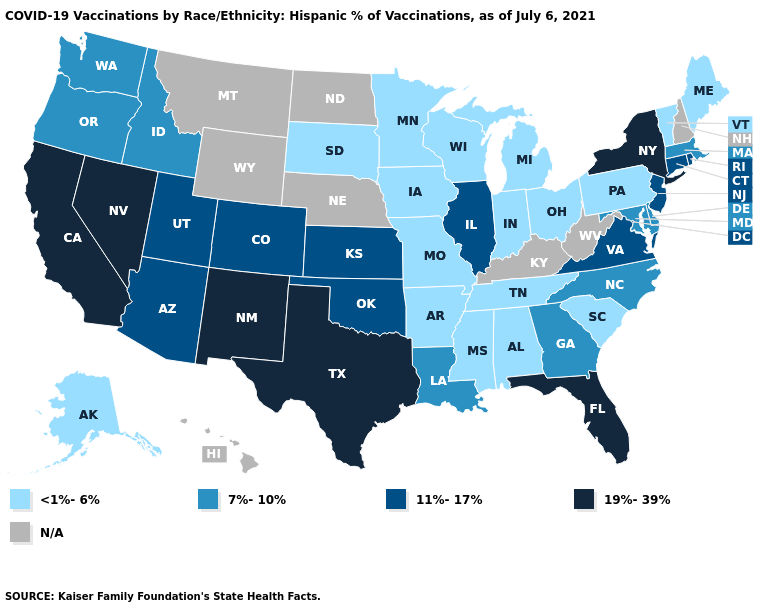Does Illinois have the highest value in the MidWest?
Short answer required. Yes. Does Pennsylvania have the lowest value in the USA?
Keep it brief. Yes. Name the states that have a value in the range N/A?
Be succinct. Hawaii, Kentucky, Montana, Nebraska, New Hampshire, North Dakota, West Virginia, Wyoming. Among the states that border New Mexico , does Texas have the highest value?
Keep it brief. Yes. What is the value of Iowa?
Concise answer only. <1%-6%. Name the states that have a value in the range 11%-17%?
Be succinct. Arizona, Colorado, Connecticut, Illinois, Kansas, New Jersey, Oklahoma, Rhode Island, Utah, Virginia. What is the highest value in the USA?
Keep it brief. 19%-39%. Does Louisiana have the lowest value in the USA?
Give a very brief answer. No. What is the value of Ohio?
Write a very short answer. <1%-6%. Name the states that have a value in the range <1%-6%?
Answer briefly. Alabama, Alaska, Arkansas, Indiana, Iowa, Maine, Michigan, Minnesota, Mississippi, Missouri, Ohio, Pennsylvania, South Carolina, South Dakota, Tennessee, Vermont, Wisconsin. What is the highest value in states that border Arizona?
Answer briefly. 19%-39%. What is the highest value in states that border Alabama?
Give a very brief answer. 19%-39%. Name the states that have a value in the range <1%-6%?
Short answer required. Alabama, Alaska, Arkansas, Indiana, Iowa, Maine, Michigan, Minnesota, Mississippi, Missouri, Ohio, Pennsylvania, South Carolina, South Dakota, Tennessee, Vermont, Wisconsin. Name the states that have a value in the range <1%-6%?
Concise answer only. Alabama, Alaska, Arkansas, Indiana, Iowa, Maine, Michigan, Minnesota, Mississippi, Missouri, Ohio, Pennsylvania, South Carolina, South Dakota, Tennessee, Vermont, Wisconsin. 